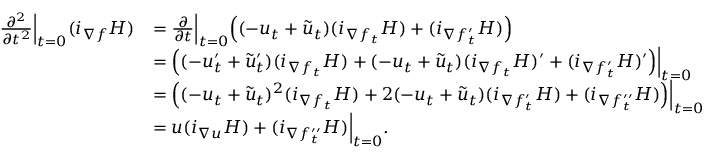<formula> <loc_0><loc_0><loc_500><loc_500>\begin{array} { r l } { \frac { \partial ^ { 2 } } { \partial t ^ { 2 } } \Big | _ { t = 0 } ( i _ { \nabla f } H ) } & { = \frac { \partial } { \partial t } \Big | _ { t = 0 } \Big ( ( - u _ { t } + \tilde { u } _ { t } ) ( i _ { \nabla { f _ { t } } } H ) + ( i _ { \nabla { f _ { t } ^ { \prime } } } H ) \Big ) } \\ & { = \Big ( ( - u _ { t } ^ { \prime } + \tilde { u } _ { t } ^ { \prime } ) ( i _ { \nabla { f _ { t } } } H ) + ( - u _ { t } + \tilde { u } _ { t } ) ( i _ { \nabla { f _ { t } } } H ) ^ { \prime } + ( i _ { \nabla { f _ { t } ^ { \prime } } } H ) ^ { \prime } \Big ) \Big | _ { t = 0 } } \\ & { = \Big ( ( - u _ { t } + \tilde { u } _ { t } ) ^ { 2 } ( i _ { \nabla { f _ { t } } } H ) + 2 ( - u _ { t } + \tilde { u } _ { t } ) ( i _ { \nabla { f _ { t } ^ { \prime } } } H ) + ( i _ { \nabla { f _ { t } ^ { \prime \prime } } } H ) \Big ) \Big | _ { t = 0 } } \\ & { = u ( i _ { \nabla u } H ) + ( i _ { \nabla { f _ { t } ^ { \prime \prime } } } H ) \Big | _ { t = 0 } . } \end{array}</formula> 